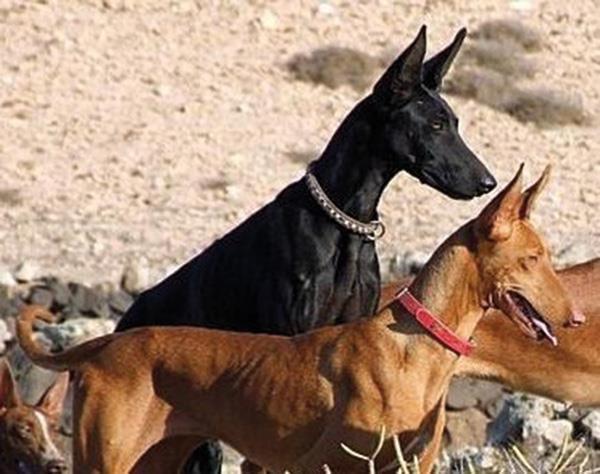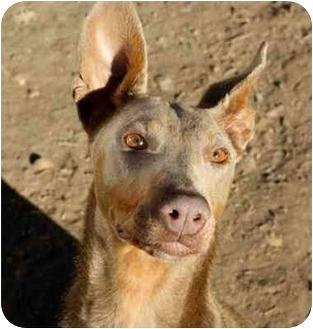The first image is the image on the left, the second image is the image on the right. For the images shown, is this caption "The left and right image contains the same number of dogs." true? Answer yes or no. No. The first image is the image on the left, the second image is the image on the right. Evaluate the accuracy of this statement regarding the images: "All the dogs are laying down.". Is it true? Answer yes or no. No. 